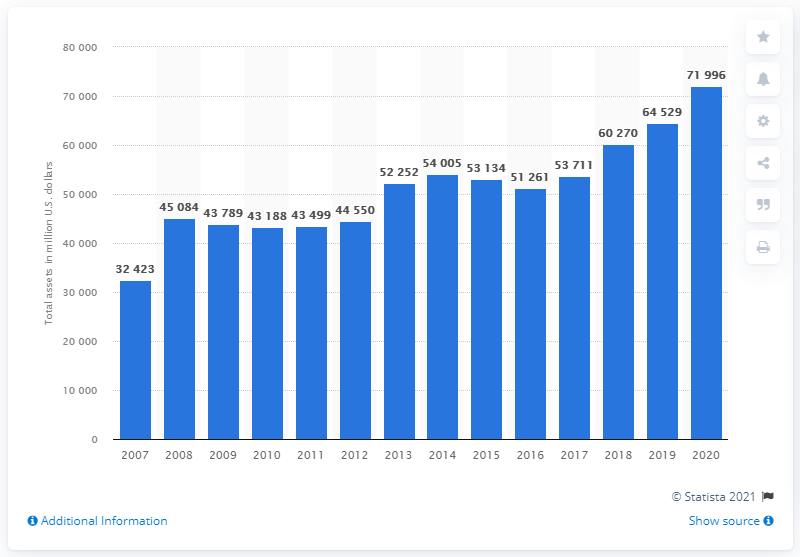Outline some significant characteristics in this image. The value of Delta's assets in the fiscal year of 2020 was 71,996. In the year 2007, Delta's last fiscal year occurred. 